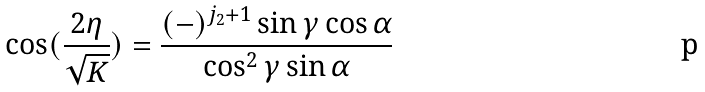<formula> <loc_0><loc_0><loc_500><loc_500>\cos ( \frac { 2 \eta } { \sqrt { K } } ) = \frac { ( - ) ^ { j _ { 2 } + 1 } \sin \gamma \cos \alpha } { \cos ^ { 2 } \gamma \sin \alpha }</formula> 